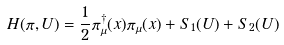Convert formula to latex. <formula><loc_0><loc_0><loc_500><loc_500>H ( \pi , U ) = \frac { 1 } { 2 } \pi ^ { \dagger } _ { \mu } ( x ) \pi _ { \mu } ( x ) + S _ { 1 } ( U ) + S _ { 2 } ( U )</formula> 